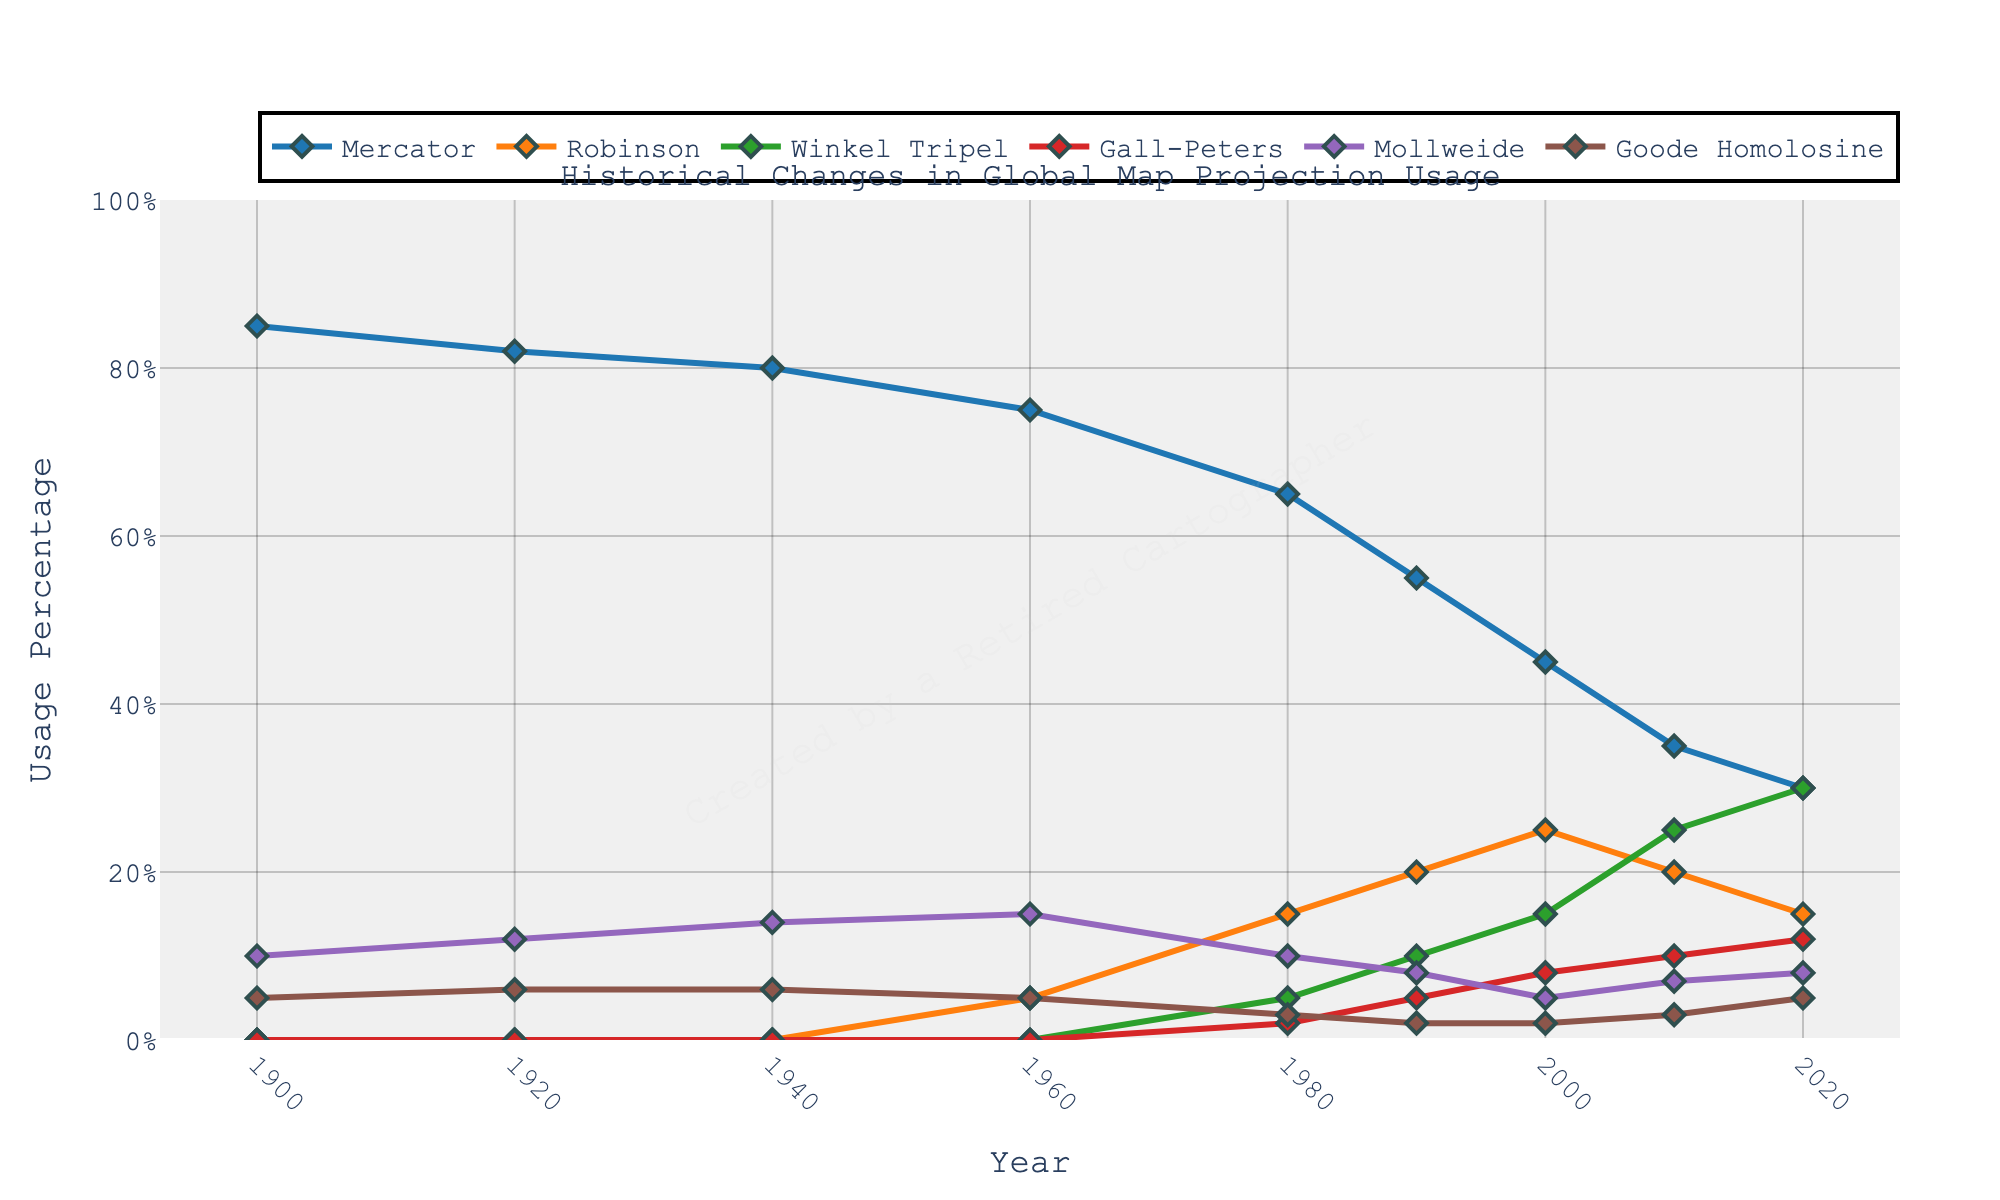Which map projection shows the highest usage percentage in 1940? The figure shows the usage percentages of different map projections over time. In 1940, the highest line graph belongs to Mercator projection.
Answer: Mercator By how much did the usage percentage of Mercator decrease between 1900 and 2020? The usage percentage of Mercator was 85% in 1900 and 30% in 2020. The difference is 85% - 30%.
Answer: 55% Which map projections first appear in the figure around 1960? The figure starts tracing some lines that appear around 1960. The lines that begin around this year correspond to Robinson and Winkel Tripel projections.
Answer: Robinson and Winkel Tripel What is the total usage percentage of Gall-Peters and Mollweide projections in 2020? In 2020, Gall-Peters has a usage percentage of 12% and Mollweide has 8%. Adding these gives the total usage.
Answer: 20% Was there ever a year where Mollweide had higher usage than Gall-Peters? By examining the figure, Mollweide has a consistently lower percentage than Gall-Peters for all the years presented.
Answer: No Between which years did Robinson projection show the greatest increase in usage percentage? The figure shows the increase in the Robinson line graph mainly from 1980 to 2000. We calculate the difference between these years (25% - 15% for 2000 vs. 1980).
Answer: 1980 to 2000 What visual attributes did you notice for the trace of Mercator projection in the figure? The Mercator projection trace is marked with blue-colored lines and diamond-shaped markers.
Answer: Blue with diamond markers Which year shows the closest usage percentage between Winkel Tripel and Gall-Peters projections? In 2010, the usage percentages for Winkel Tripel and Gall-Peters are close (25% and 10%). The graph indicates that the difference is smallest around 2010.
Answer: 2010 Compare the usage percentage of Goode Homolosine projection in 1920 with its value in 1980. In 1920, Goode Homolosine has a usage percentage of 6%, while in 1980 it has decreased to 3%.
Answer: 1920 (6%) is higher than 1980 (3%) What is the approximate average usage percentage of the Mollweide projection from 1900 to 2020? To find this, add the usage percentages from 1900, 1920, ... 2020 (10% + 12% + 14% + 15% + 10% + 8% + 5% + 7% + 8%) and divide by the number of years (9). The sum is 79% and the average is approximately 79%/9.
Answer: 8.78% 